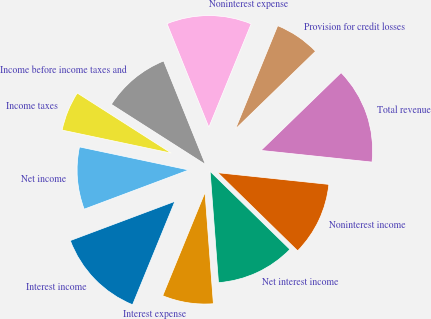Convert chart to OTSL. <chart><loc_0><loc_0><loc_500><loc_500><pie_chart><fcel>Interest income<fcel>Interest expense<fcel>Net interest income<fcel>Noninterest income<fcel>Total revenue<fcel>Provision for credit losses<fcel>Noninterest expense<fcel>Income before income taxes and<fcel>Income taxes<fcel>Net income<nl><fcel>13.11%<fcel>7.38%<fcel>11.48%<fcel>10.66%<fcel>13.93%<fcel>6.56%<fcel>12.29%<fcel>9.84%<fcel>5.74%<fcel>9.02%<nl></chart> 